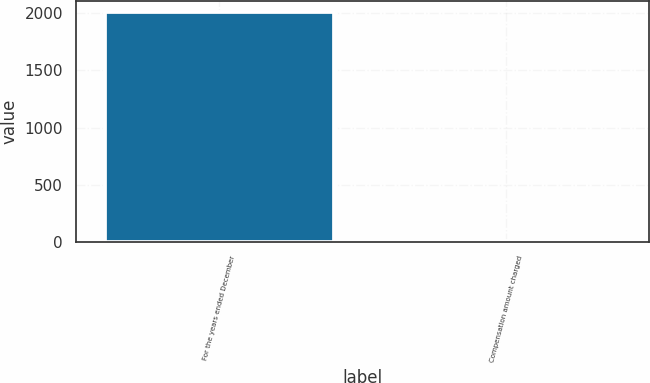Convert chart to OTSL. <chart><loc_0><loc_0><loc_500><loc_500><bar_chart><fcel>For the years ended December<fcel>Compensation amount charged<nl><fcel>2008<fcel>9.1<nl></chart> 